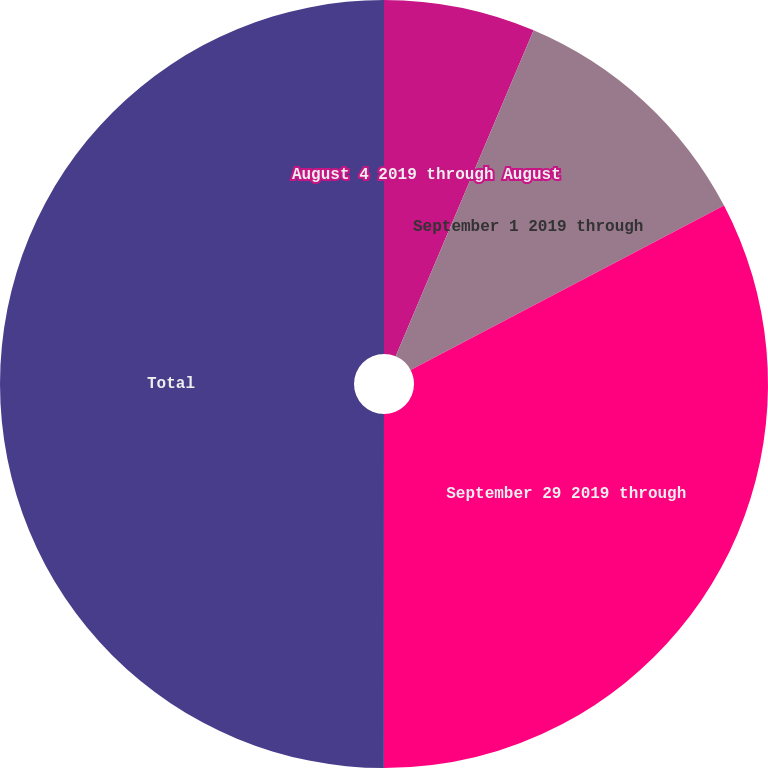Convert chart to OTSL. <chart><loc_0><loc_0><loc_500><loc_500><pie_chart><fcel>August 4 2019 through August<fcel>September 1 2019 through<fcel>September 29 2019 through<fcel>Total<nl><fcel>6.37%<fcel>10.94%<fcel>32.7%<fcel>50.0%<nl></chart> 